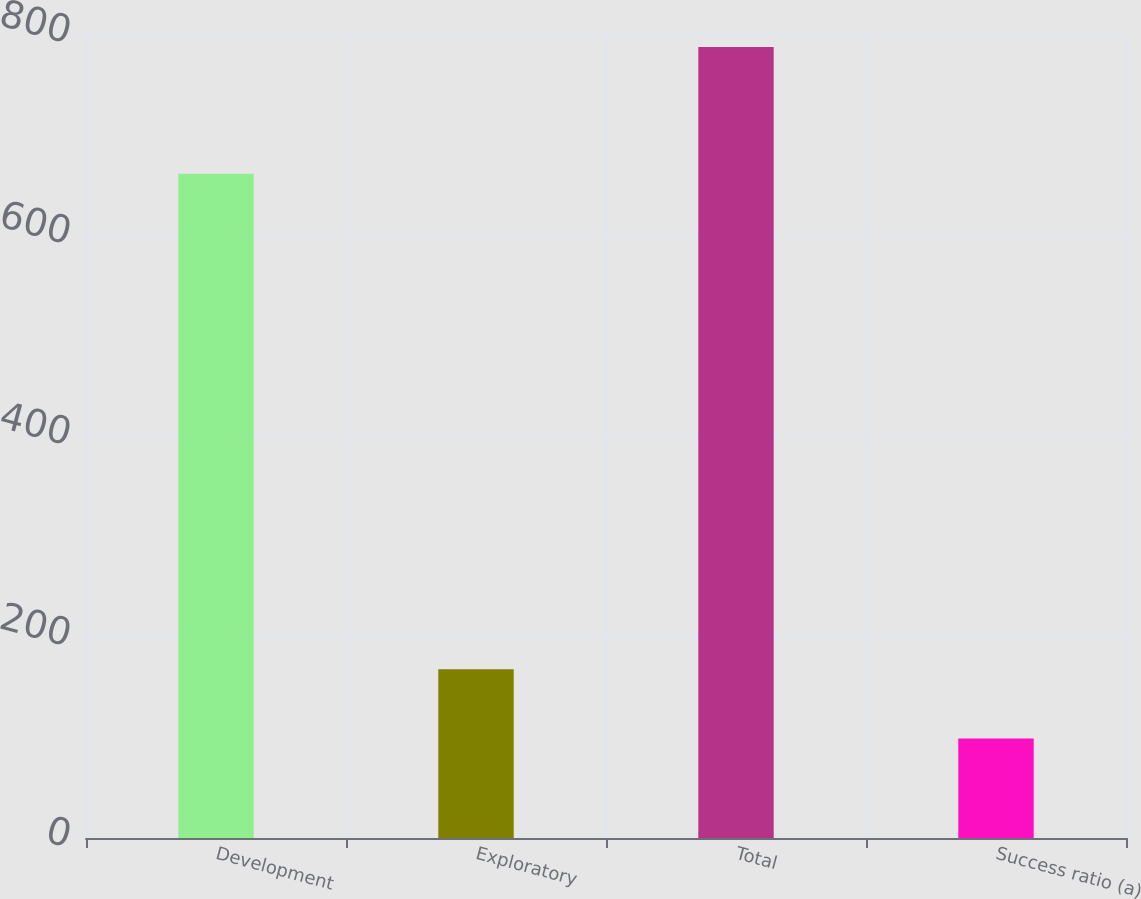Convert chart to OTSL. <chart><loc_0><loc_0><loc_500><loc_500><bar_chart><fcel>Development<fcel>Exploratory<fcel>Total<fcel>Success ratio (a)<nl><fcel>661<fcel>167.8<fcel>787<fcel>99<nl></chart> 